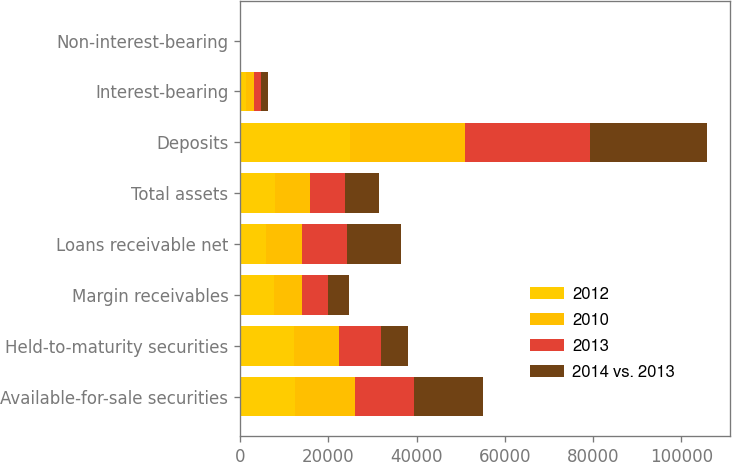<chart> <loc_0><loc_0><loc_500><loc_500><stacked_bar_chart><ecel><fcel>Available-for-sale securities<fcel>Held-to-maturity securities<fcel>Margin receivables<fcel>Loans receivable net<fcel>Total assets<fcel>Deposits<fcel>Interest-bearing<fcel>Non-interest-bearing<nl><fcel>2012<fcel>12388<fcel>12248<fcel>7675<fcel>5979<fcel>7899<fcel>24890<fcel>1328<fcel>38<nl><fcel>2010<fcel>13592<fcel>10181<fcel>6353<fcel>8123<fcel>7899<fcel>25971<fcel>1726<fcel>42<nl><fcel>2013<fcel>13443<fcel>9540<fcel>5804<fcel>10099<fcel>7899<fcel>28393<fcel>1722<fcel>43<nl><fcel>2014 vs. 2013<fcel>15651<fcel>6080<fcel>4826<fcel>12333<fcel>7899<fcel>26460<fcel>1451<fcel>43<nl></chart> 